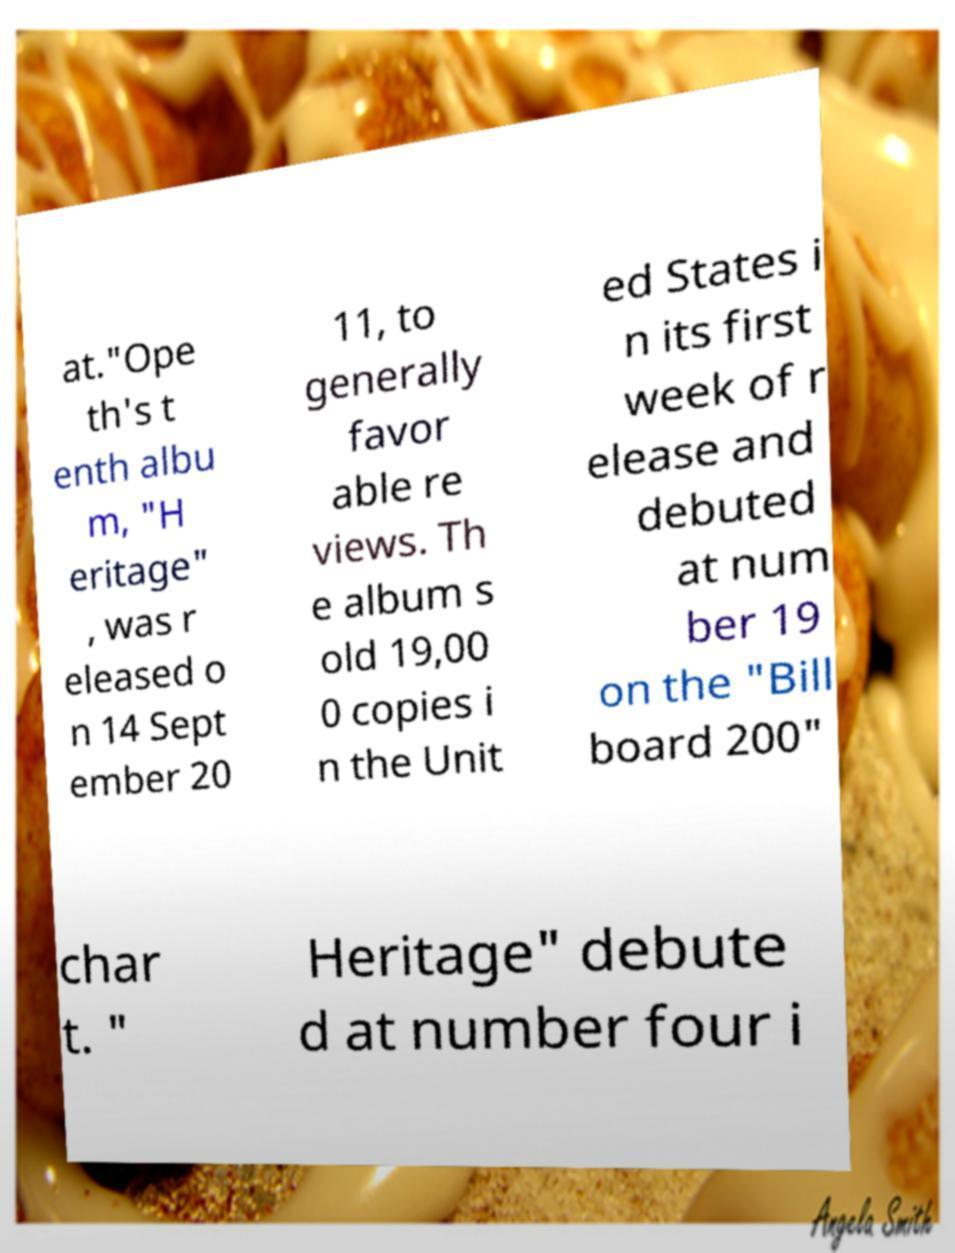Could you extract and type out the text from this image? at."Ope th's t enth albu m, "H eritage" , was r eleased o n 14 Sept ember 20 11, to generally favor able re views. Th e album s old 19,00 0 copies i n the Unit ed States i n its first week of r elease and debuted at num ber 19 on the "Bill board 200" char t. " Heritage" debute d at number four i 